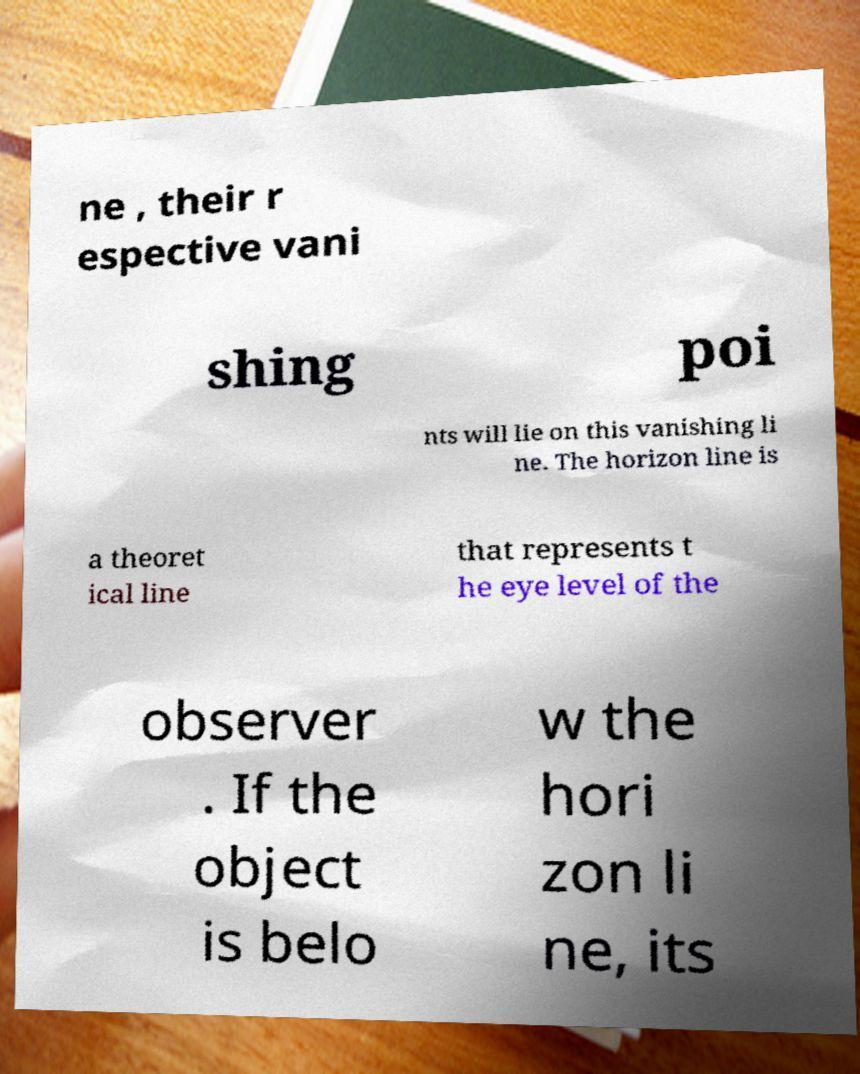Please read and relay the text visible in this image. What does it say? ne , their r espective vani shing poi nts will lie on this vanishing li ne. The horizon line is a theoret ical line that represents t he eye level of the observer . If the object is belo w the hori zon li ne, its 